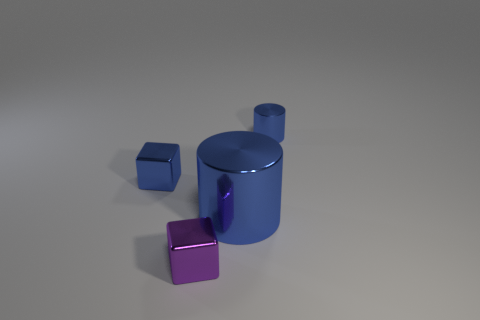Add 4 tiny metallic objects. How many objects exist? 8 Subtract all tiny yellow rubber spheres. Subtract all shiny things. How many objects are left? 0 Add 4 large metallic cylinders. How many large metallic cylinders are left? 5 Add 1 tiny green blocks. How many tiny green blocks exist? 1 Subtract 0 purple cylinders. How many objects are left? 4 